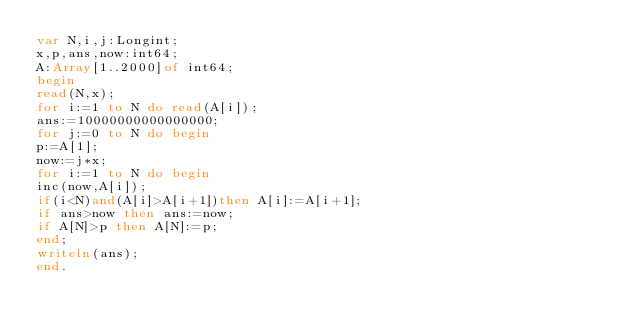<code> <loc_0><loc_0><loc_500><loc_500><_Pascal_>var N,i,j:Longint;
x,p,ans,now:int64;
A:Array[1..2000]of int64;
begin
read(N,x);
for i:=1 to N do read(A[i]);
ans:=10000000000000000;
for j:=0 to N do begin
p:=A[1];
now:=j*x;
for i:=1 to N do begin
inc(now,A[i]);
if(i<N)and(A[i]>A[i+1])then A[i]:=A[i+1];
if ans>now then ans:=now;
if A[N]>p then A[N]:=p;
end;
writeln(ans);
end.</code> 